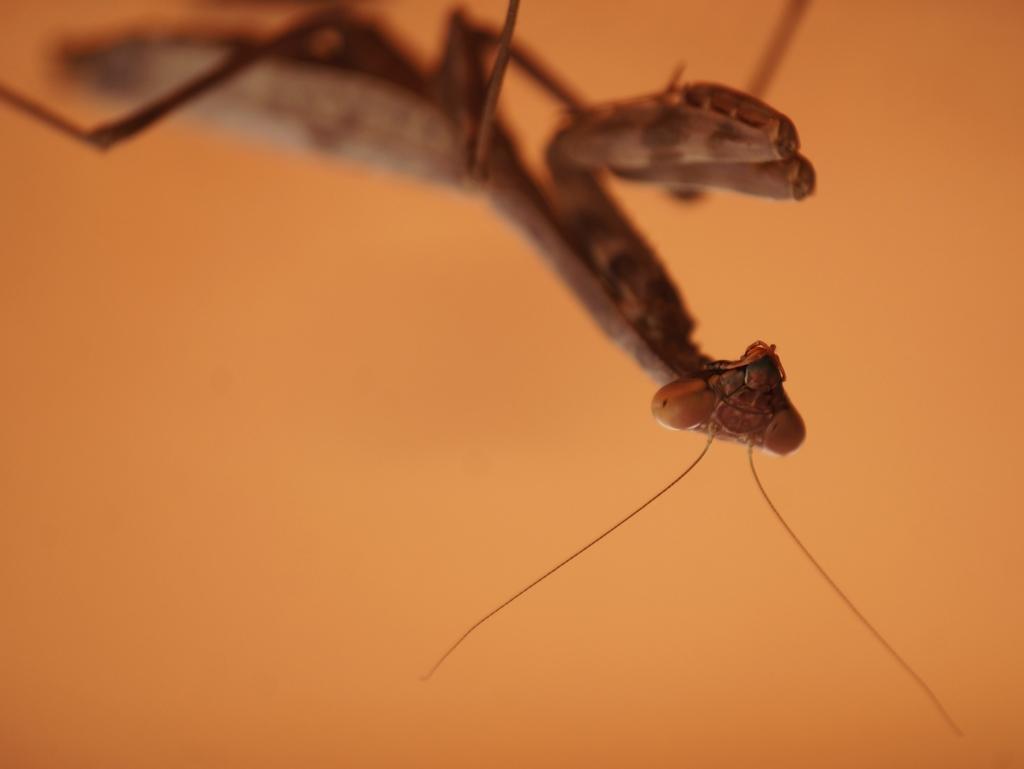In one or two sentences, can you explain what this image depicts? In this image there is a grasshopper which is in brown color. Background is in orange color. 